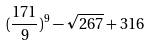<formula> <loc_0><loc_0><loc_500><loc_500>( \frac { 1 7 1 } { 9 } ) ^ { 9 } - \sqrt { 2 6 7 } + 3 1 6</formula> 